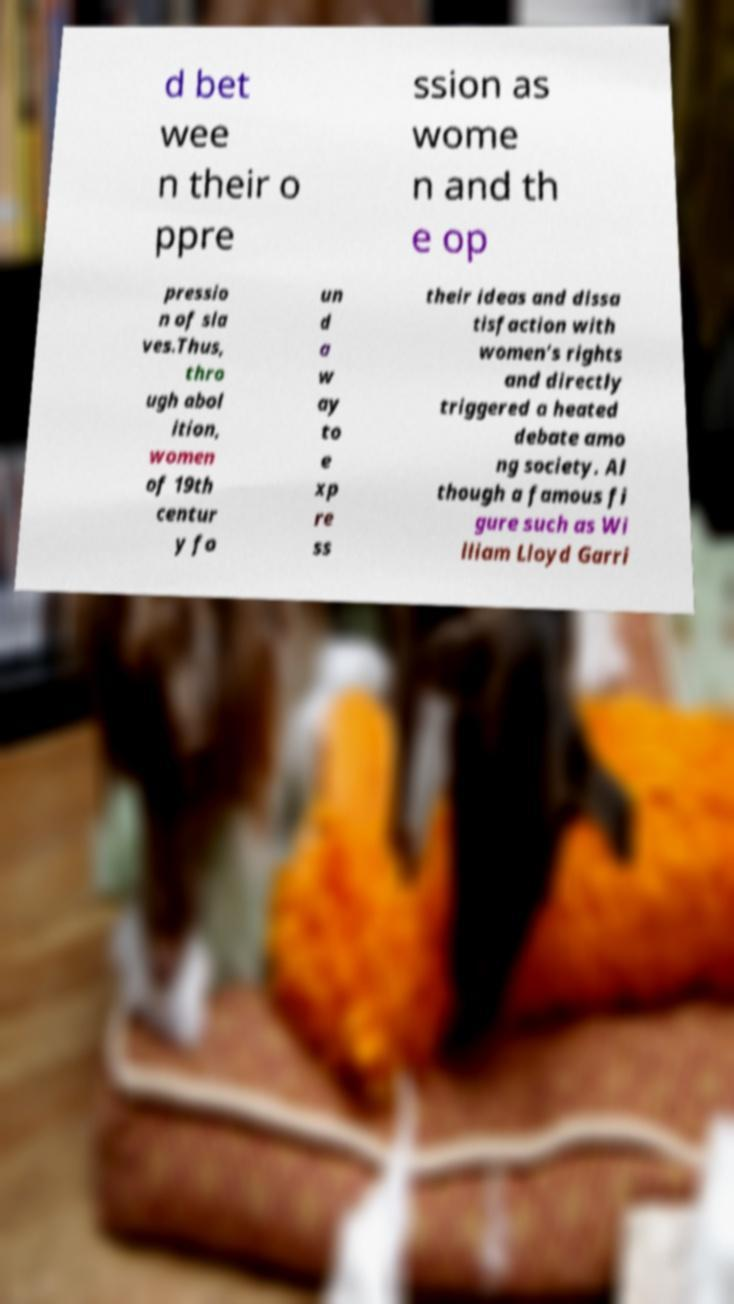Can you accurately transcribe the text from the provided image for me? d bet wee n their o ppre ssion as wome n and th e op pressio n of sla ves.Thus, thro ugh abol ition, women of 19th centur y fo un d a w ay to e xp re ss their ideas and dissa tisfaction with women’s rights and directly triggered a heated debate amo ng society. Al though a famous fi gure such as Wi lliam Lloyd Garri 